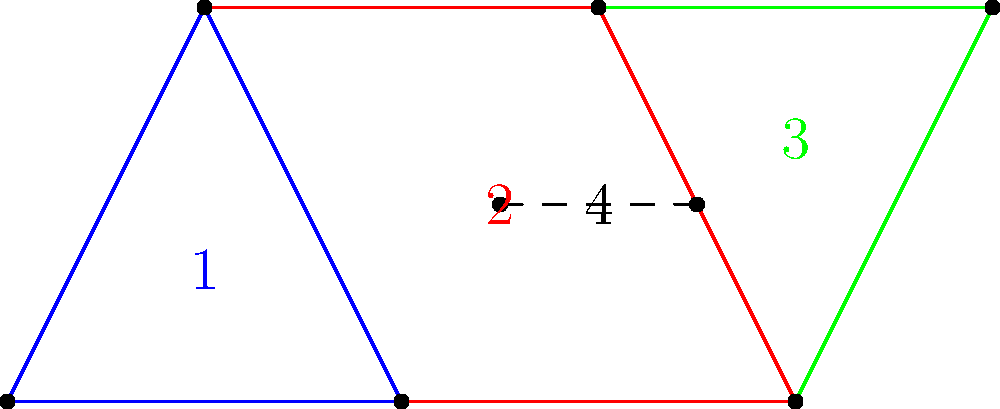In this intricate geometric pattern, which we've discussed in our art sessions, identify all the congruent triangles. Label your findings using the numbers assigned to each shape in the diagram. Let's approach this step-by-step, as we often do when analyzing compositions:

1) First, let's identify the triangles:
   - Triangle 1 is ABC (blue)
   - Triangle 2 is CDE (part of the red quadrilateral)
   - Triangle 3 is DEF (green)

2) To determine congruence, we need to check if the triangles have the same shape and size. We can do this by comparing side lengths and angles.

3) Let's start with triangle 1 (ABC) and triangle 2 (CDE):
   - AB = DE (base of the figure)
   - BC = CD (sides of the figure)
   - AC = CE (diagonals of the rectangle BCDE)
   
   Since all three sides are equal, by the SSS (Side-Side-Side) congruence criterion, triangles ABC and CDE are congruent.

4) Now, let's compare triangle 2 (CDE) and triangle 3 (DEF):
   - DE is common to both triangles
   - CD = EF (sides of the figure)
   - CE = DF (diagonals of the rectangle CDEF)
   
   Again, all three sides are equal, so by SSS, triangles CDE and DEF are also congruent.

5) By the transitive property, if triangle 1 is congruent to triangle 2, and triangle 2 is congruent to triangle 3, then triangle 1 is also congruent to triangle 3.

Therefore, all three triangles (1, 2, and 3) are congruent to each other.
Answer: 1, 2, and 3 